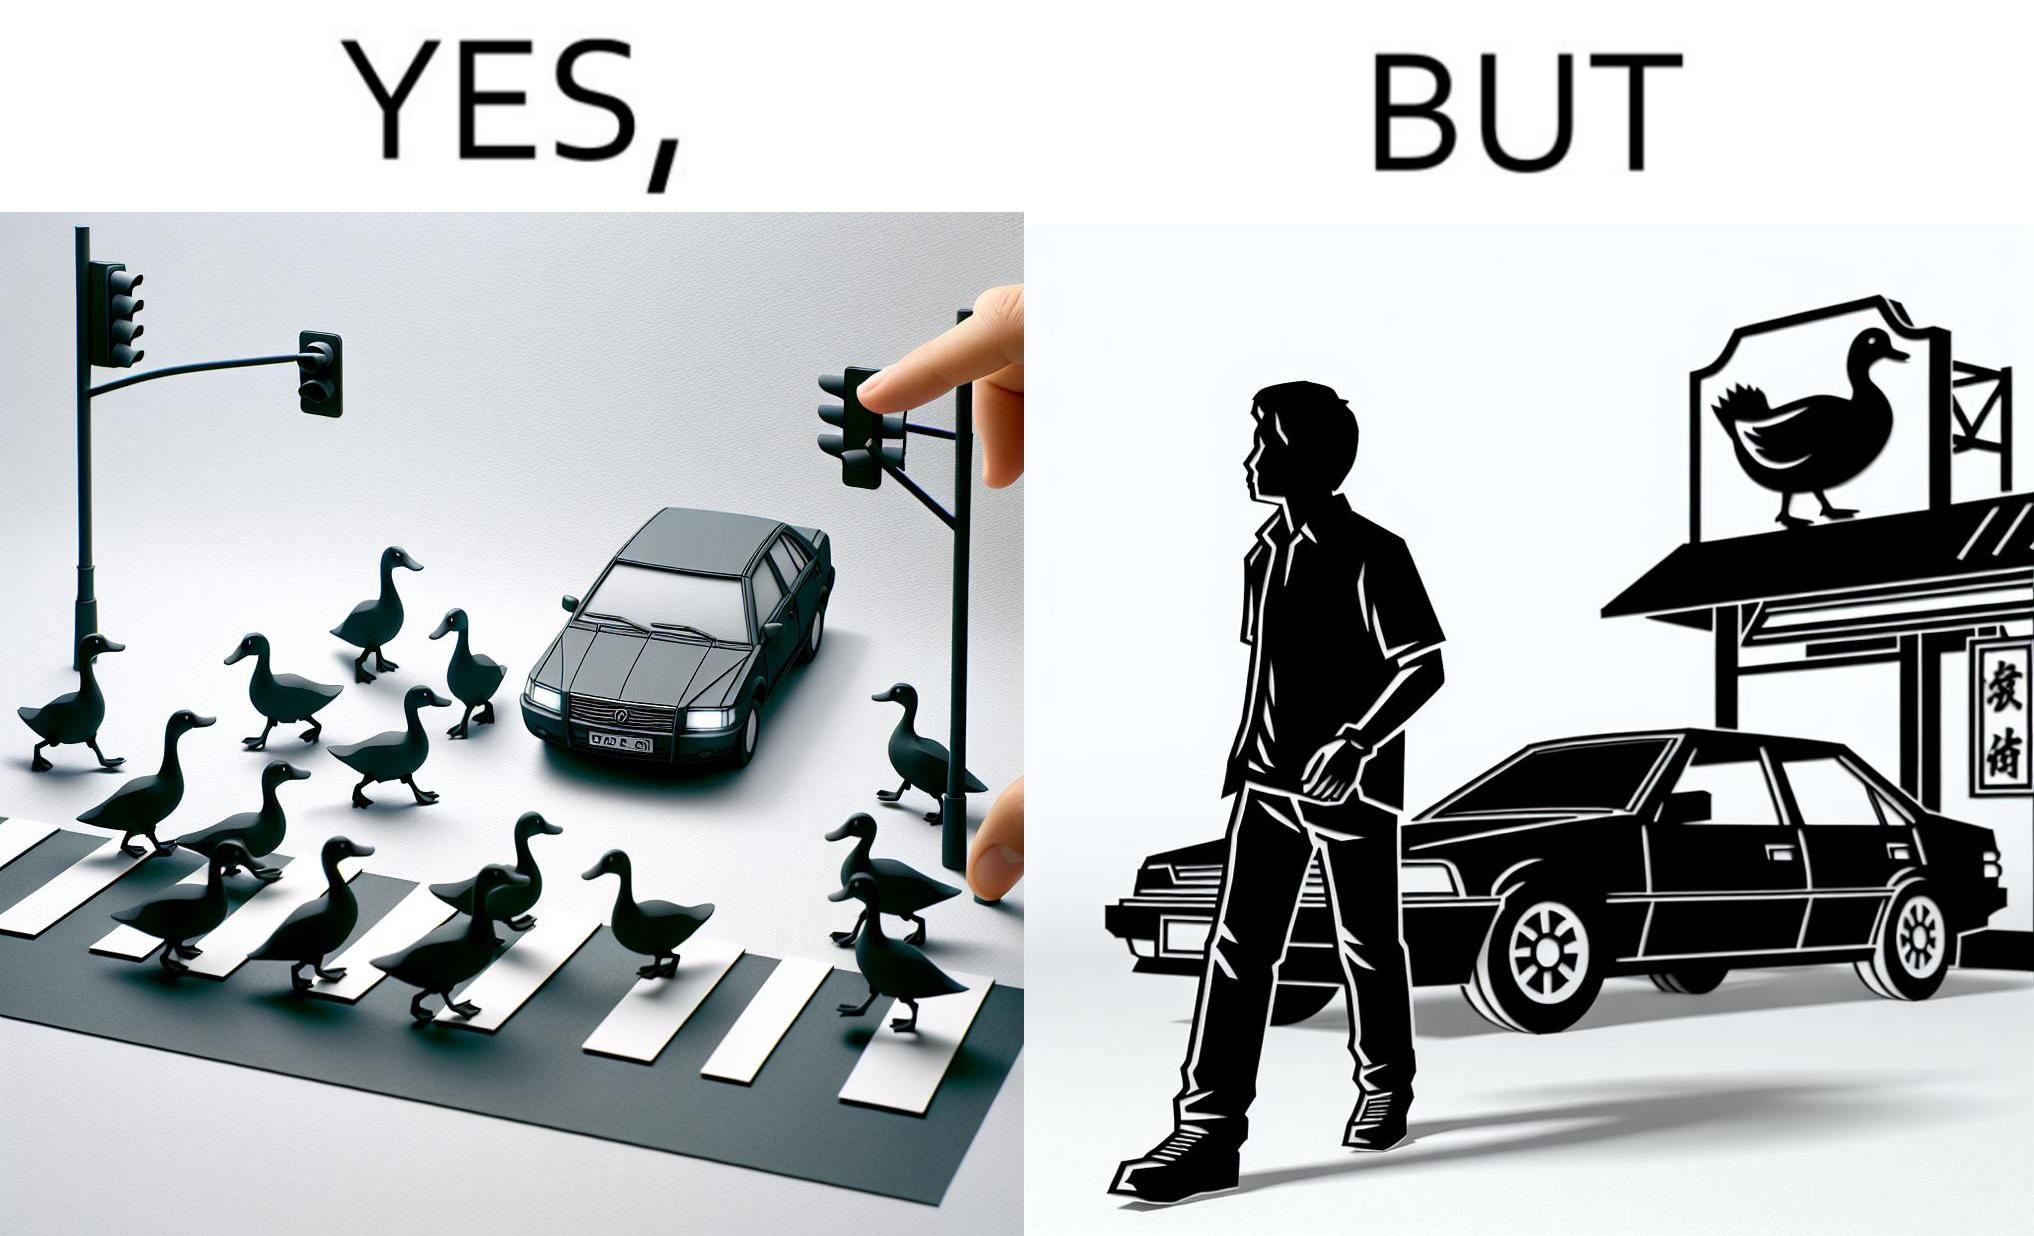Describe what you see in the left and right parts of this image. In the left part of the image: It is a car stopping to give way to queue of ducks crossing the road and allow them to cross safely In the right part of the image: It is a man parking his car and entering a peking duck shop 